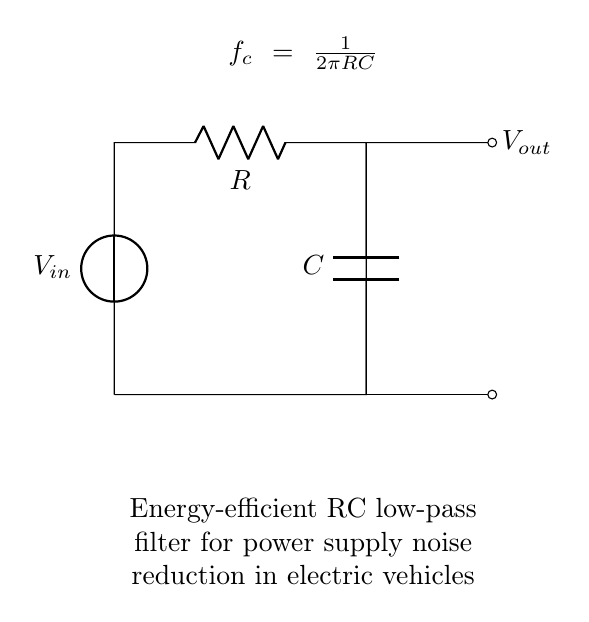What are the components in this circuit? The circuit consists of a voltage source, a resistor, and a capacitor. Each component is clearly labeled in the diagram. The voltage source is marked as V_in, the resistor is labeled as R, and the capacitor is labeled as C.
Answer: Voltage source, resistor, capacitor What is the function of the resistor in this circuit? The resistor in this low-pass filter circuit helps to limit the current flow and defines the cutoff frequency along with the capacitor. It affects how quickly the voltage across the capacitor can change.
Answer: Current limitation What is the cutoff frequency formula shown in the circuit? The formula for the cutoff frequency is given as f_c = 1/(2πRC). This relationship indicates how the frequency response of the low-pass filter is determined by the resistor and capacitor values.
Answer: f_c = 1/(2πRC) How does the capacitor affect the circuit's operation? The capacitor stores electrical energy and its charging and discharging behavior determines the filter's response to voltage changes. It helps smoothen out voltage fluctuations, thus reducing noise.
Answer: Energy storage What is the output voltage connection point in this circuit? The output voltage is taken from the point labeled V_out, which is connected after the resistor and capacitor parallel connection. This point reflects the smoothed voltage output.
Answer: V_out What does the circuit accomplish regarding power supply in electric vehicles? This RC low-pass filter effectively reduces power supply noise, enhancing the stability and performance of electric vehicle electronics by filtering out high-frequency signals.
Answer: Noise reduction 